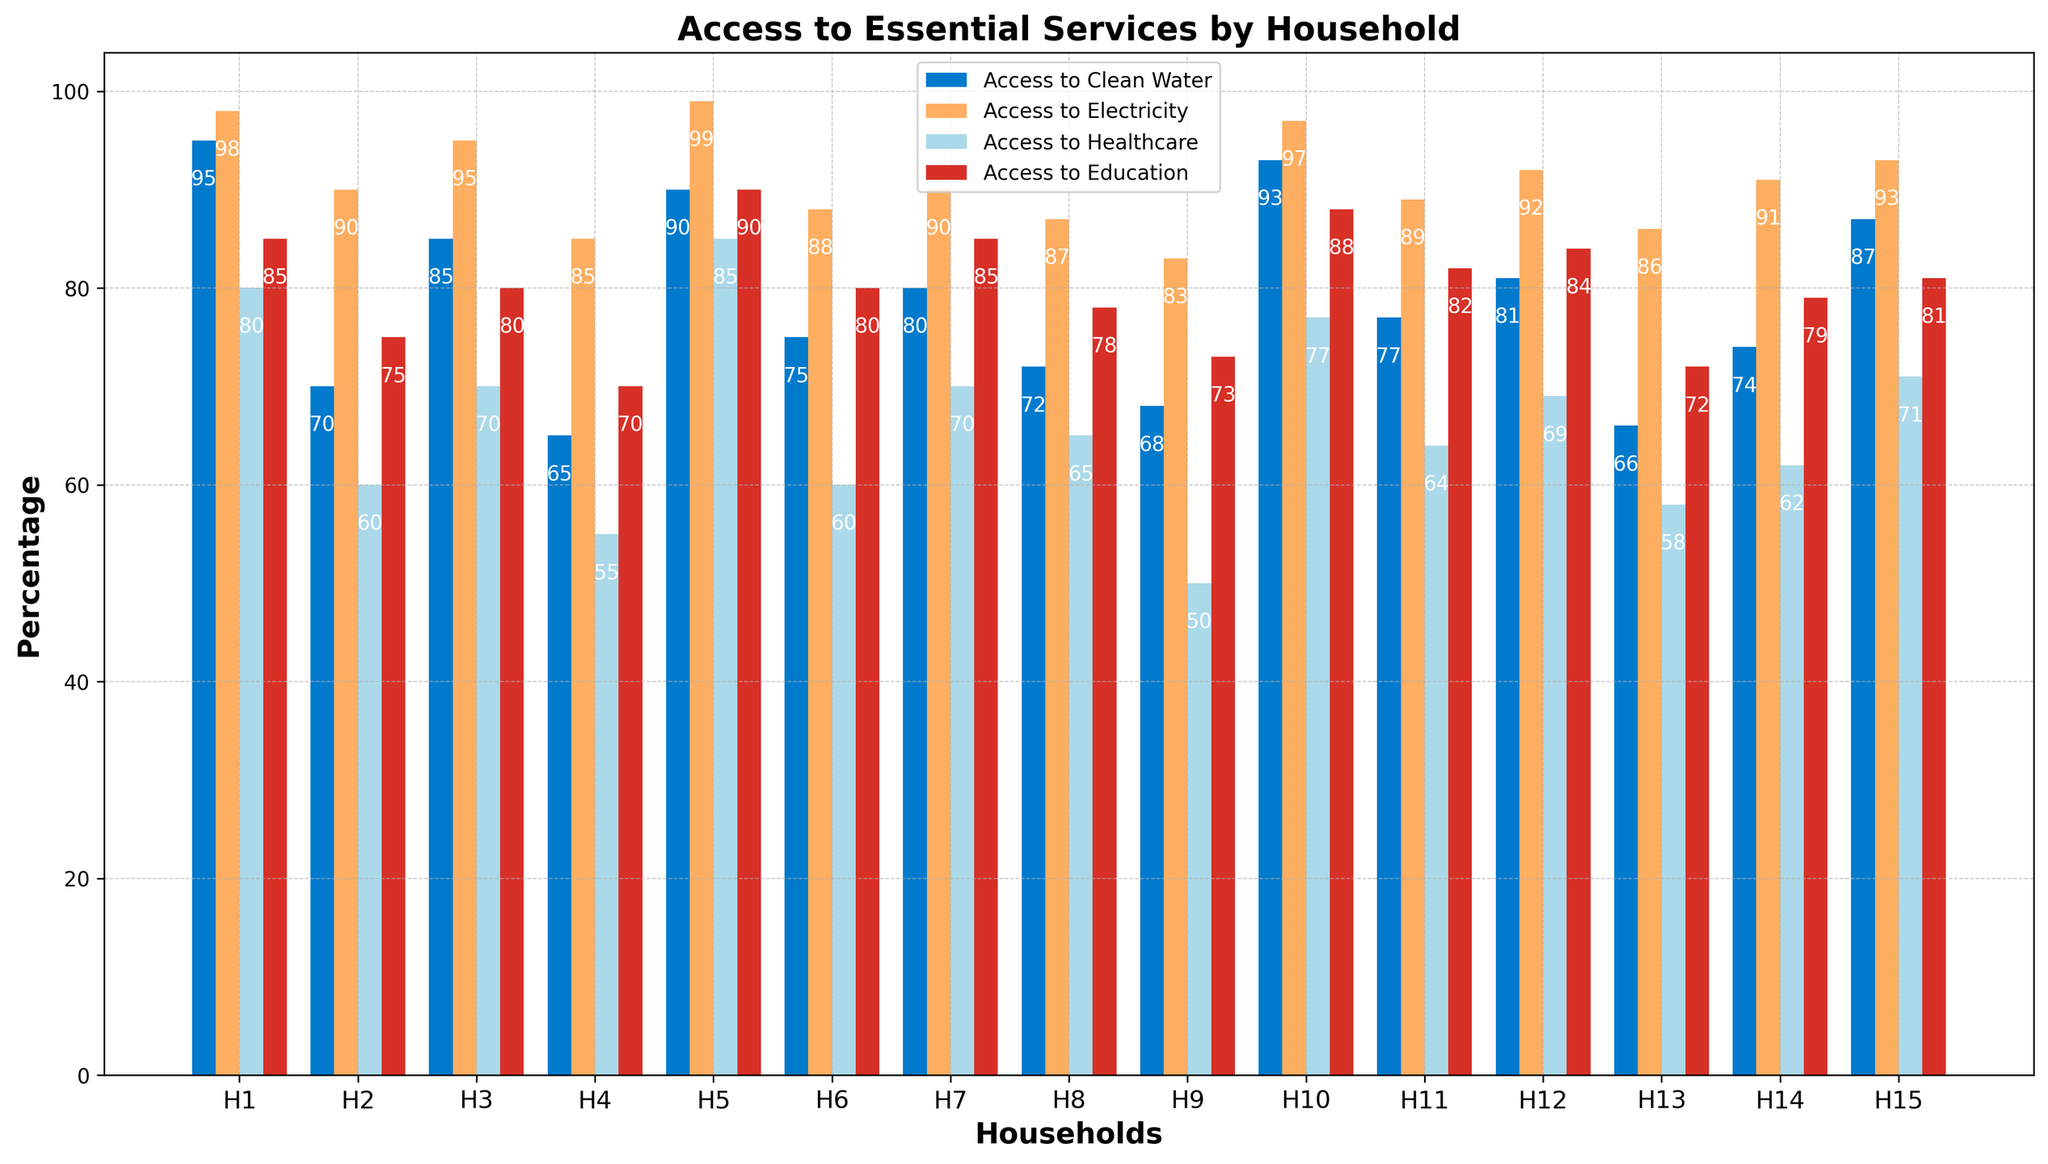What's the percentage of households with access to clean water higher than 90%? Looking at the bar chart, we identify households where the blue bars (clean water) exceed the 90% level. These households are H1, H5, H10, and H15. So, four households out of fifteen have access to clean water higher than 90%.
Answer: Four households Which household has the lowest access to healthcare? In the chart, the light blue bars represent access to healthcare. By comparing the height of these bars, we see that Household 9 has the lowest bar.
Answer: Household 9 What is the average access to electricity across all households? To find this, add the access to electricity percentages for all households and divide by the number of households. The sum is 98 + 90 + 95 + 85 + 99 + 88 + 90 + 87 + 83 + 97 + 89 + 92 + 86 + 91 + 93 = 1353. The number of households is 15. Therefore, the average is 1353 / 15 = 90.2%.
Answer: 90.2% Which essential service has the most variation in access across households? This requires visual comparison of the heights of the bars of different colors. The bars representing access to clean water (blue) and electricity (orange) tend to be uniformly high, while the bars for healthcare (light blue) and education (red) show more variability in height.
Answer: Healthcare Which household has the highest access to education and what is that percentage? By looking at the red bars, we see Household 5 has the highest access to education. The top of the red bar indicates a percentage of around 90%.
Answer: Household 5 with 90% What's the difference in access to clean water between households 1 and 4? Household 1 has an access of 95%, and Household 4 has an access of 65%. Subtracting 65 from 95 gives a difference of 30%.
Answer: 30% Which household shows the most balanced access to all four services? A balanced access would mean the heights of the four bars for a single household are very similar. By comparing, Household 12 seems to have relatively consistent bar heights across all services, with access values of 81%, 92%, 69%, and 84%.
Answer: Household 12 What's the total percentage of access to essential services for Household 7? Adding the percentages for all four services for Household 7: 80% (Clean Water) + 90% (Electricity) + 70% (Healthcare) + 85% (Education) = 325%.
Answer: 325% Which two households have the closest access to healthcare? By examining the light blue bars, Households 3 and 7 both seem to have access values of 70%.
Answer: Households 3 and 7 Is there any household that has access to all services greater than 80%? By looking at all bar heights above the 80% mark, Household 1 meets this criterion with access percentages of 95%, 98%, 80%, and 85%.
Answer: Household 1 